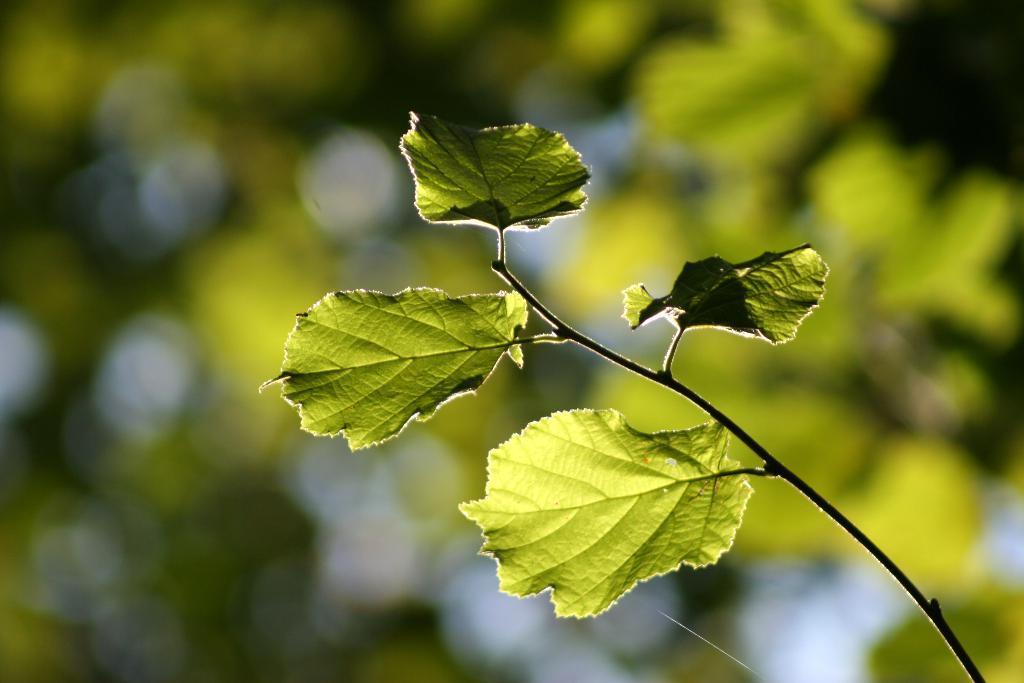Can you describe this image briefly? In this image, we can see a branch on blur background. 